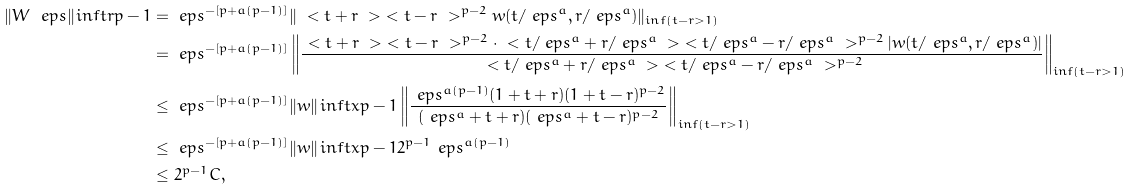Convert formula to latex. <formula><loc_0><loc_0><loc_500><loc_500>\| W _ { \ } e p s \| _ { \L } i n f t r { p - 1 } & = \ e p s ^ { - [ p + a ( p - 1 ) ] } \| \ < t + r \ > \ < t - r \ > ^ { p - 2 } w ( t / \ e p s ^ { a } , r / \ e p s ^ { a } ) \| _ { \L i n f ( t - r > 1 ) } \\ & = \ e p s ^ { - [ p + a ( p - 1 ) ] } \left \| \frac { \ < t + r \ > \ < t - r \ > ^ { p - 2 } \cdot \ < t / \ e p s ^ { a } + r / \ e p s ^ { a } \ > \ < t / \ e p s ^ { a } - r / \ e p s ^ { a } \ > ^ { p - 2 } | w ( t / \ e p s ^ { a } , r / \ e p s ^ { a } ) | } { \ < t / \ e p s ^ { a } + r / \ e p s ^ { a } \ > \ < t / \ e p s ^ { a } - r / \ e p s ^ { a } \ > ^ { p - 2 } } \right \| _ { \L i n f ( t - r > 1 ) } \\ & \leq \ e p s ^ { - [ p + a ( p - 1 ) ] } \| w \| _ { \L } i n f t x { p - 1 } \left \| \frac { \ e p s ^ { a ( p - 1 ) } ( 1 + t + r ) ( 1 + t - r ) ^ { p - 2 } } { ( \ e p s ^ { a } + t + r ) ( \ e p s ^ { a } + t - r ) ^ { p - 2 } } \right \| _ { \L i n f ( t - r > 1 ) } \\ & \leq \ e p s ^ { - [ p + a ( p - 1 ) ] } \| w \| _ { \L } i n f t x { p - 1 } 2 ^ { p - 1 } \ e p s ^ { a ( p - 1 ) } \\ & \leq 2 ^ { p - 1 } C ,</formula> 